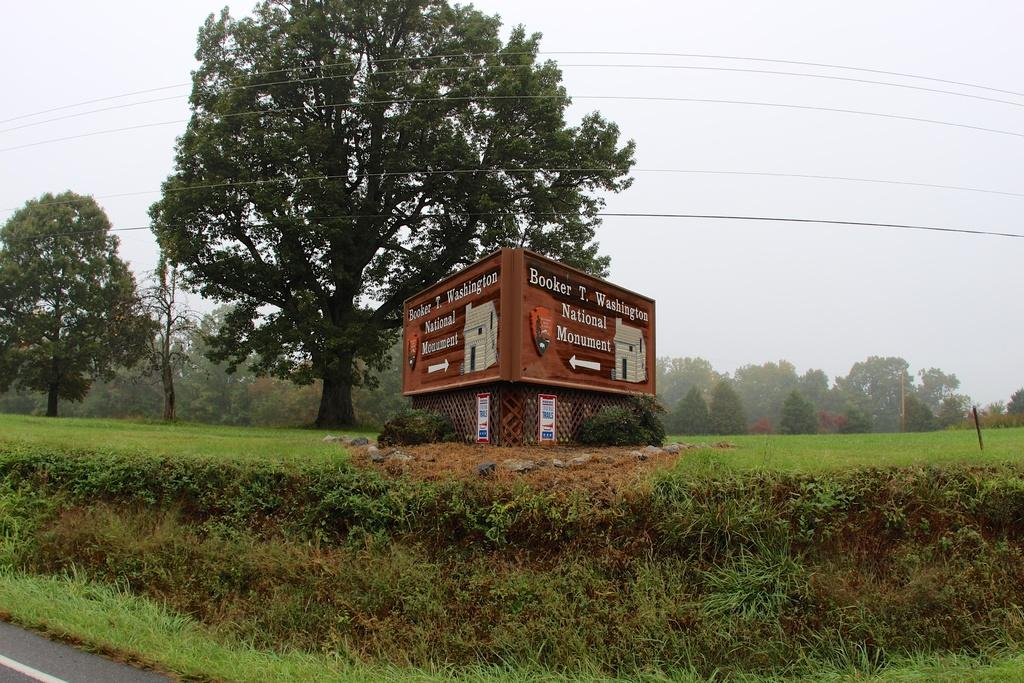What is the main feature of the image? There is a road in the image. What can be seen next to the road? Grass is visible next to the road, and there are brown-colored boards next to it. What is visible in the background of the image? There are many trees and wires in the background of the image, as well as the sky. What type of bean is growing on the brown-colored boards in the image? There are no beans present in the image; the brown-colored boards are not related to any plant growth. How does the fuel consumption of the vehicles on the road affect the image? There are no vehicles or fuel consumption mentioned in the image, so it cannot be determined how it would affect the image. 